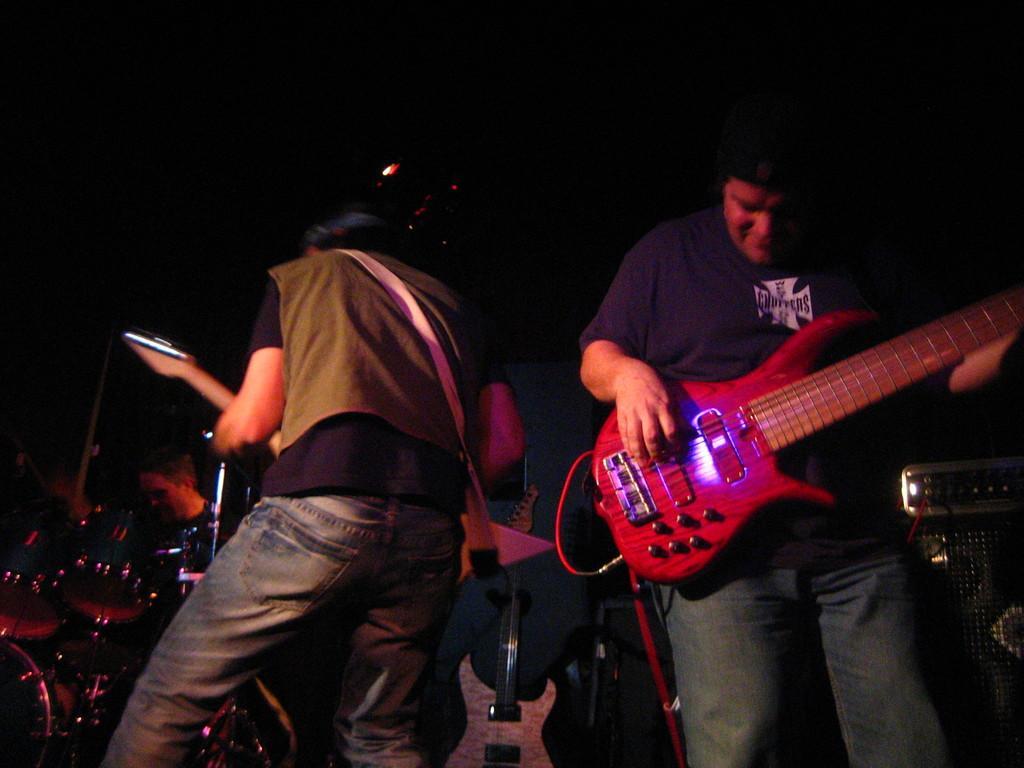Could you give a brief overview of what you see in this image? In this image there are two persons who are standing and they are playing a guitar and on the left side there are drums and one person is there, and on the right side there is one sound system. 